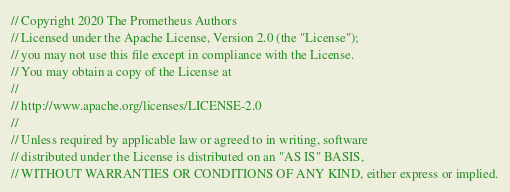Convert code to text. <code><loc_0><loc_0><loc_500><loc_500><_Go_>// Copyright 2020 The Prometheus Authors
// Licensed under the Apache License, Version 2.0 (the "License");
// you may not use this file except in compliance with the License.
// You may obtain a copy of the License at
//
// http://www.apache.org/licenses/LICENSE-2.0
//
// Unless required by applicable law or agreed to in writing, software
// distributed under the License is distributed on an "AS IS" BASIS,
// WITHOUT WARRANTIES OR CONDITIONS OF ANY KIND, either express or implied.</code> 